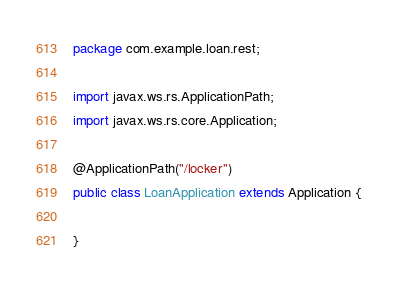<code> <loc_0><loc_0><loc_500><loc_500><_Java_>package com.example.loan.rest;

import javax.ws.rs.ApplicationPath;
import javax.ws.rs.core.Application;

@ApplicationPath("/locker")
public class LoanApplication extends Application {

}
</code> 